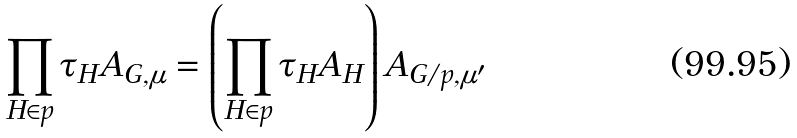<formula> <loc_0><loc_0><loc_500><loc_500>\prod _ { H \in p } \tau _ { H } A _ { G , \mu } = \left ( \prod _ { H \in p } \tau _ { H } A _ { H } \right ) A _ { G / p , \mu ^ { \prime } }</formula> 